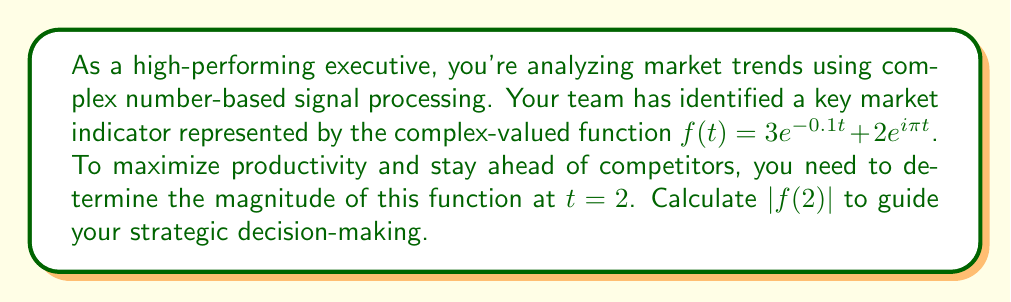Give your solution to this math problem. Let's approach this step-by-step:

1) We start with the given function: $f(t) = 3e^{-0.1t} + 2e^{i\pi t}$

2) We need to evaluate this at $t = 2$:
   $f(2) = 3e^{-0.1(2)} + 2e^{i\pi(2)}$

3) Simplify:
   $f(2) = 3e^{-0.2} + 2e^{2\pi i}$

4) Recall that $e^{2\pi i} = 1$ (Euler's formula):
   $f(2) = 3e^{-0.2} + 2$

5) Calculate $e^{-0.2} \approx 0.8187$:
   $f(2) \approx 3(0.8187) + 2 \approx 2.4561 + 2 = 4.4561$

6) Now, we have $f(2)$ in the form $a + bi$ where $a = 4.4561$ and $b = 0$

7) The magnitude of a complex number $a + bi$ is given by $\sqrt{a^2 + b^2}$

8) Therefore, $|f(2)| = \sqrt{4.4561^2 + 0^2} = \sqrt{19.8568} \approx 4.4561$

This value represents the strength of the market indicator at time $t = 2$, crucial for making time-sensitive strategic decisions in a competitive business environment.
Answer: $|f(2)| \approx 4.4561$ 